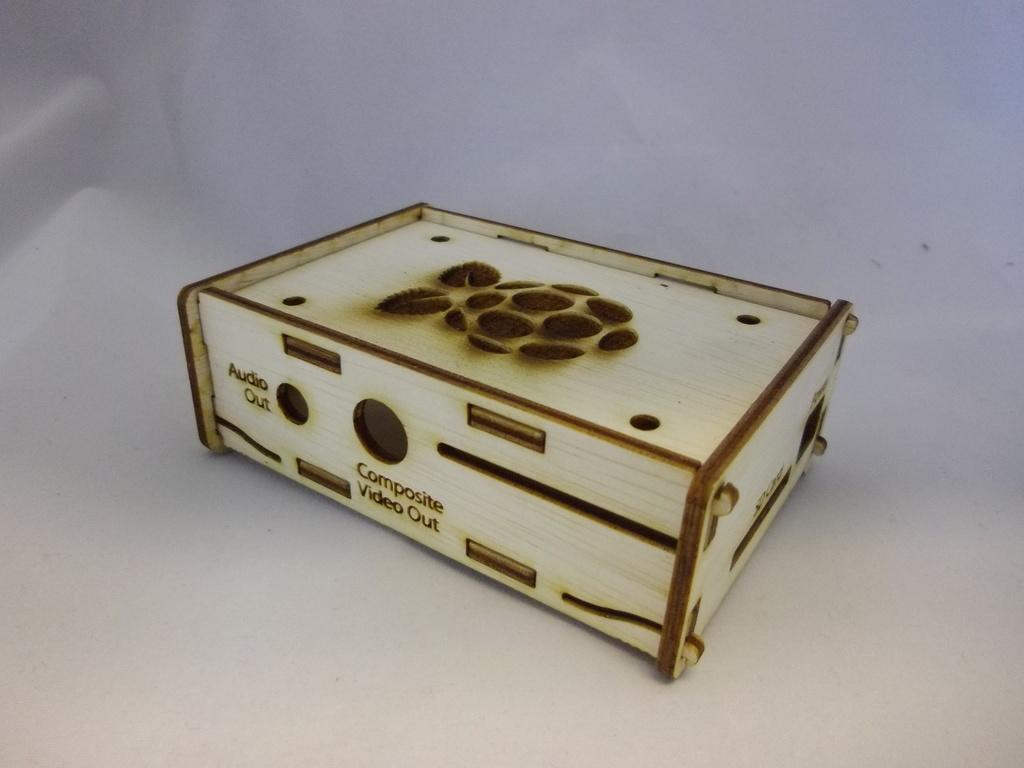<image>
Relay a brief, clear account of the picture shown. The box contains an audio out button on the left hand side. 